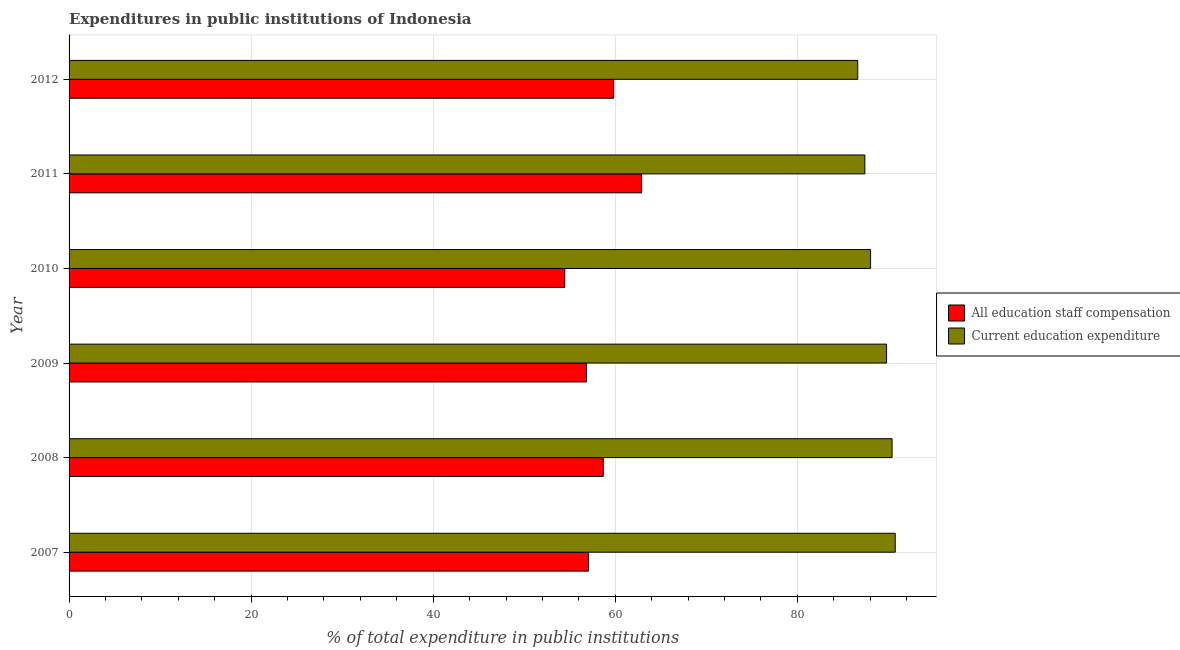What is the label of the 6th group of bars from the top?
Provide a succinct answer. 2007. In how many cases, is the number of bars for a given year not equal to the number of legend labels?
Ensure brevity in your answer.  0. What is the expenditure in education in 2010?
Make the answer very short. 88.05. Across all years, what is the maximum expenditure in education?
Ensure brevity in your answer.  90.76. Across all years, what is the minimum expenditure in staff compensation?
Your answer should be compact. 54.45. What is the total expenditure in staff compensation in the graph?
Ensure brevity in your answer.  349.77. What is the difference between the expenditure in staff compensation in 2008 and that in 2011?
Offer a very short reply. -4.21. What is the difference between the expenditure in staff compensation in 2012 and the expenditure in education in 2009?
Offer a terse response. -29.98. What is the average expenditure in staff compensation per year?
Give a very brief answer. 58.3. In the year 2012, what is the difference between the expenditure in staff compensation and expenditure in education?
Give a very brief answer. -26.82. In how many years, is the expenditure in staff compensation greater than 64 %?
Give a very brief answer. 0. What is the difference between the highest and the second highest expenditure in education?
Provide a succinct answer. 0.34. What is the difference between the highest and the lowest expenditure in staff compensation?
Keep it short and to the point. 8.44. What does the 1st bar from the top in 2010 represents?
Make the answer very short. Current education expenditure. What does the 1st bar from the bottom in 2011 represents?
Provide a succinct answer. All education staff compensation. How many bars are there?
Provide a succinct answer. 12. How many years are there in the graph?
Offer a very short reply. 6. Are the values on the major ticks of X-axis written in scientific E-notation?
Make the answer very short. No. Does the graph contain any zero values?
Offer a very short reply. No. Where does the legend appear in the graph?
Your response must be concise. Center right. How many legend labels are there?
Your response must be concise. 2. What is the title of the graph?
Your answer should be compact. Expenditures in public institutions of Indonesia. What is the label or title of the X-axis?
Ensure brevity in your answer.  % of total expenditure in public institutions. What is the % of total expenditure in public institutions in All education staff compensation in 2007?
Ensure brevity in your answer.  57.07. What is the % of total expenditure in public institutions of Current education expenditure in 2007?
Offer a very short reply. 90.76. What is the % of total expenditure in public institutions of All education staff compensation in 2008?
Your answer should be compact. 58.68. What is the % of total expenditure in public institutions in Current education expenditure in 2008?
Provide a short and direct response. 90.42. What is the % of total expenditure in public institutions of All education staff compensation in 2009?
Ensure brevity in your answer.  56.84. What is the % of total expenditure in public institutions of Current education expenditure in 2009?
Your response must be concise. 89.81. What is the % of total expenditure in public institutions in All education staff compensation in 2010?
Ensure brevity in your answer.  54.45. What is the % of total expenditure in public institutions in Current education expenditure in 2010?
Offer a terse response. 88.05. What is the % of total expenditure in public institutions of All education staff compensation in 2011?
Offer a very short reply. 62.89. What is the % of total expenditure in public institutions of Current education expenditure in 2011?
Offer a very short reply. 87.43. What is the % of total expenditure in public institutions of All education staff compensation in 2012?
Your answer should be very brief. 59.83. What is the % of total expenditure in public institutions of Current education expenditure in 2012?
Ensure brevity in your answer.  86.64. Across all years, what is the maximum % of total expenditure in public institutions in All education staff compensation?
Ensure brevity in your answer.  62.89. Across all years, what is the maximum % of total expenditure in public institutions in Current education expenditure?
Your answer should be compact. 90.76. Across all years, what is the minimum % of total expenditure in public institutions of All education staff compensation?
Make the answer very short. 54.45. Across all years, what is the minimum % of total expenditure in public institutions in Current education expenditure?
Offer a terse response. 86.64. What is the total % of total expenditure in public institutions in All education staff compensation in the graph?
Offer a very short reply. 349.77. What is the total % of total expenditure in public institutions of Current education expenditure in the graph?
Ensure brevity in your answer.  533.11. What is the difference between the % of total expenditure in public institutions of All education staff compensation in 2007 and that in 2008?
Offer a very short reply. -1.61. What is the difference between the % of total expenditure in public institutions in Current education expenditure in 2007 and that in 2008?
Offer a very short reply. 0.34. What is the difference between the % of total expenditure in public institutions in All education staff compensation in 2007 and that in 2009?
Keep it short and to the point. 0.23. What is the difference between the % of total expenditure in public institutions in Current education expenditure in 2007 and that in 2009?
Offer a very short reply. 0.95. What is the difference between the % of total expenditure in public institutions of All education staff compensation in 2007 and that in 2010?
Your answer should be very brief. 2.62. What is the difference between the % of total expenditure in public institutions in Current education expenditure in 2007 and that in 2010?
Make the answer very short. 2.71. What is the difference between the % of total expenditure in public institutions in All education staff compensation in 2007 and that in 2011?
Offer a very short reply. -5.82. What is the difference between the % of total expenditure in public institutions in Current education expenditure in 2007 and that in 2011?
Provide a short and direct response. 3.33. What is the difference between the % of total expenditure in public institutions of All education staff compensation in 2007 and that in 2012?
Provide a succinct answer. -2.75. What is the difference between the % of total expenditure in public institutions of Current education expenditure in 2007 and that in 2012?
Provide a succinct answer. 4.12. What is the difference between the % of total expenditure in public institutions of All education staff compensation in 2008 and that in 2009?
Ensure brevity in your answer.  1.84. What is the difference between the % of total expenditure in public institutions of Current education expenditure in 2008 and that in 2009?
Make the answer very short. 0.6. What is the difference between the % of total expenditure in public institutions of All education staff compensation in 2008 and that in 2010?
Ensure brevity in your answer.  4.23. What is the difference between the % of total expenditure in public institutions of Current education expenditure in 2008 and that in 2010?
Your answer should be compact. 2.36. What is the difference between the % of total expenditure in public institutions of All education staff compensation in 2008 and that in 2011?
Ensure brevity in your answer.  -4.21. What is the difference between the % of total expenditure in public institutions of Current education expenditure in 2008 and that in 2011?
Your response must be concise. 2.99. What is the difference between the % of total expenditure in public institutions in All education staff compensation in 2008 and that in 2012?
Offer a very short reply. -1.15. What is the difference between the % of total expenditure in public institutions in Current education expenditure in 2008 and that in 2012?
Make the answer very short. 3.77. What is the difference between the % of total expenditure in public institutions in All education staff compensation in 2009 and that in 2010?
Offer a very short reply. 2.39. What is the difference between the % of total expenditure in public institutions in Current education expenditure in 2009 and that in 2010?
Your answer should be compact. 1.76. What is the difference between the % of total expenditure in public institutions of All education staff compensation in 2009 and that in 2011?
Your answer should be compact. -6.05. What is the difference between the % of total expenditure in public institutions in Current education expenditure in 2009 and that in 2011?
Make the answer very short. 2.39. What is the difference between the % of total expenditure in public institutions in All education staff compensation in 2009 and that in 2012?
Keep it short and to the point. -2.99. What is the difference between the % of total expenditure in public institutions in Current education expenditure in 2009 and that in 2012?
Provide a succinct answer. 3.17. What is the difference between the % of total expenditure in public institutions in All education staff compensation in 2010 and that in 2011?
Your answer should be very brief. -8.44. What is the difference between the % of total expenditure in public institutions of Current education expenditure in 2010 and that in 2011?
Keep it short and to the point. 0.63. What is the difference between the % of total expenditure in public institutions in All education staff compensation in 2010 and that in 2012?
Offer a terse response. -5.37. What is the difference between the % of total expenditure in public institutions in Current education expenditure in 2010 and that in 2012?
Make the answer very short. 1.41. What is the difference between the % of total expenditure in public institutions of All education staff compensation in 2011 and that in 2012?
Provide a short and direct response. 3.07. What is the difference between the % of total expenditure in public institutions in Current education expenditure in 2011 and that in 2012?
Your answer should be very brief. 0.78. What is the difference between the % of total expenditure in public institutions in All education staff compensation in 2007 and the % of total expenditure in public institutions in Current education expenditure in 2008?
Keep it short and to the point. -33.34. What is the difference between the % of total expenditure in public institutions in All education staff compensation in 2007 and the % of total expenditure in public institutions in Current education expenditure in 2009?
Your answer should be compact. -32.74. What is the difference between the % of total expenditure in public institutions in All education staff compensation in 2007 and the % of total expenditure in public institutions in Current education expenditure in 2010?
Your response must be concise. -30.98. What is the difference between the % of total expenditure in public institutions of All education staff compensation in 2007 and the % of total expenditure in public institutions of Current education expenditure in 2011?
Ensure brevity in your answer.  -30.35. What is the difference between the % of total expenditure in public institutions in All education staff compensation in 2007 and the % of total expenditure in public institutions in Current education expenditure in 2012?
Give a very brief answer. -29.57. What is the difference between the % of total expenditure in public institutions in All education staff compensation in 2008 and the % of total expenditure in public institutions in Current education expenditure in 2009?
Your answer should be compact. -31.13. What is the difference between the % of total expenditure in public institutions of All education staff compensation in 2008 and the % of total expenditure in public institutions of Current education expenditure in 2010?
Ensure brevity in your answer.  -29.37. What is the difference between the % of total expenditure in public institutions of All education staff compensation in 2008 and the % of total expenditure in public institutions of Current education expenditure in 2011?
Offer a very short reply. -28.74. What is the difference between the % of total expenditure in public institutions of All education staff compensation in 2008 and the % of total expenditure in public institutions of Current education expenditure in 2012?
Give a very brief answer. -27.96. What is the difference between the % of total expenditure in public institutions of All education staff compensation in 2009 and the % of total expenditure in public institutions of Current education expenditure in 2010?
Make the answer very short. -31.21. What is the difference between the % of total expenditure in public institutions of All education staff compensation in 2009 and the % of total expenditure in public institutions of Current education expenditure in 2011?
Give a very brief answer. -30.59. What is the difference between the % of total expenditure in public institutions in All education staff compensation in 2009 and the % of total expenditure in public institutions in Current education expenditure in 2012?
Keep it short and to the point. -29.8. What is the difference between the % of total expenditure in public institutions in All education staff compensation in 2010 and the % of total expenditure in public institutions in Current education expenditure in 2011?
Your answer should be very brief. -32.97. What is the difference between the % of total expenditure in public institutions in All education staff compensation in 2010 and the % of total expenditure in public institutions in Current education expenditure in 2012?
Provide a short and direct response. -32.19. What is the difference between the % of total expenditure in public institutions of All education staff compensation in 2011 and the % of total expenditure in public institutions of Current education expenditure in 2012?
Your answer should be compact. -23.75. What is the average % of total expenditure in public institutions in All education staff compensation per year?
Make the answer very short. 58.3. What is the average % of total expenditure in public institutions of Current education expenditure per year?
Your answer should be very brief. 88.85. In the year 2007, what is the difference between the % of total expenditure in public institutions of All education staff compensation and % of total expenditure in public institutions of Current education expenditure?
Ensure brevity in your answer.  -33.69. In the year 2008, what is the difference between the % of total expenditure in public institutions in All education staff compensation and % of total expenditure in public institutions in Current education expenditure?
Provide a short and direct response. -31.73. In the year 2009, what is the difference between the % of total expenditure in public institutions in All education staff compensation and % of total expenditure in public institutions in Current education expenditure?
Make the answer very short. -32.97. In the year 2010, what is the difference between the % of total expenditure in public institutions of All education staff compensation and % of total expenditure in public institutions of Current education expenditure?
Offer a very short reply. -33.6. In the year 2011, what is the difference between the % of total expenditure in public institutions of All education staff compensation and % of total expenditure in public institutions of Current education expenditure?
Offer a very short reply. -24.53. In the year 2012, what is the difference between the % of total expenditure in public institutions in All education staff compensation and % of total expenditure in public institutions in Current education expenditure?
Make the answer very short. -26.82. What is the ratio of the % of total expenditure in public institutions of All education staff compensation in 2007 to that in 2008?
Ensure brevity in your answer.  0.97. What is the ratio of the % of total expenditure in public institutions of Current education expenditure in 2007 to that in 2008?
Keep it short and to the point. 1. What is the ratio of the % of total expenditure in public institutions of Current education expenditure in 2007 to that in 2009?
Provide a short and direct response. 1.01. What is the ratio of the % of total expenditure in public institutions in All education staff compensation in 2007 to that in 2010?
Ensure brevity in your answer.  1.05. What is the ratio of the % of total expenditure in public institutions in Current education expenditure in 2007 to that in 2010?
Your response must be concise. 1.03. What is the ratio of the % of total expenditure in public institutions in All education staff compensation in 2007 to that in 2011?
Your response must be concise. 0.91. What is the ratio of the % of total expenditure in public institutions of Current education expenditure in 2007 to that in 2011?
Keep it short and to the point. 1.04. What is the ratio of the % of total expenditure in public institutions of All education staff compensation in 2007 to that in 2012?
Offer a very short reply. 0.95. What is the ratio of the % of total expenditure in public institutions in Current education expenditure in 2007 to that in 2012?
Offer a terse response. 1.05. What is the ratio of the % of total expenditure in public institutions of All education staff compensation in 2008 to that in 2009?
Make the answer very short. 1.03. What is the ratio of the % of total expenditure in public institutions of Current education expenditure in 2008 to that in 2009?
Provide a short and direct response. 1.01. What is the ratio of the % of total expenditure in public institutions of All education staff compensation in 2008 to that in 2010?
Give a very brief answer. 1.08. What is the ratio of the % of total expenditure in public institutions in Current education expenditure in 2008 to that in 2010?
Provide a succinct answer. 1.03. What is the ratio of the % of total expenditure in public institutions of All education staff compensation in 2008 to that in 2011?
Your answer should be very brief. 0.93. What is the ratio of the % of total expenditure in public institutions of Current education expenditure in 2008 to that in 2011?
Provide a short and direct response. 1.03. What is the ratio of the % of total expenditure in public institutions of All education staff compensation in 2008 to that in 2012?
Provide a short and direct response. 0.98. What is the ratio of the % of total expenditure in public institutions of Current education expenditure in 2008 to that in 2012?
Your answer should be very brief. 1.04. What is the ratio of the % of total expenditure in public institutions in All education staff compensation in 2009 to that in 2010?
Provide a short and direct response. 1.04. What is the ratio of the % of total expenditure in public institutions of Current education expenditure in 2009 to that in 2010?
Give a very brief answer. 1.02. What is the ratio of the % of total expenditure in public institutions of All education staff compensation in 2009 to that in 2011?
Ensure brevity in your answer.  0.9. What is the ratio of the % of total expenditure in public institutions of Current education expenditure in 2009 to that in 2011?
Keep it short and to the point. 1.03. What is the ratio of the % of total expenditure in public institutions of All education staff compensation in 2009 to that in 2012?
Your answer should be compact. 0.95. What is the ratio of the % of total expenditure in public institutions in Current education expenditure in 2009 to that in 2012?
Give a very brief answer. 1.04. What is the ratio of the % of total expenditure in public institutions in All education staff compensation in 2010 to that in 2011?
Ensure brevity in your answer.  0.87. What is the ratio of the % of total expenditure in public institutions in All education staff compensation in 2010 to that in 2012?
Your answer should be very brief. 0.91. What is the ratio of the % of total expenditure in public institutions of Current education expenditure in 2010 to that in 2012?
Offer a very short reply. 1.02. What is the ratio of the % of total expenditure in public institutions in All education staff compensation in 2011 to that in 2012?
Keep it short and to the point. 1.05. What is the ratio of the % of total expenditure in public institutions of Current education expenditure in 2011 to that in 2012?
Your answer should be very brief. 1.01. What is the difference between the highest and the second highest % of total expenditure in public institutions of All education staff compensation?
Provide a short and direct response. 3.07. What is the difference between the highest and the second highest % of total expenditure in public institutions in Current education expenditure?
Your answer should be very brief. 0.34. What is the difference between the highest and the lowest % of total expenditure in public institutions of All education staff compensation?
Provide a short and direct response. 8.44. What is the difference between the highest and the lowest % of total expenditure in public institutions in Current education expenditure?
Offer a terse response. 4.12. 